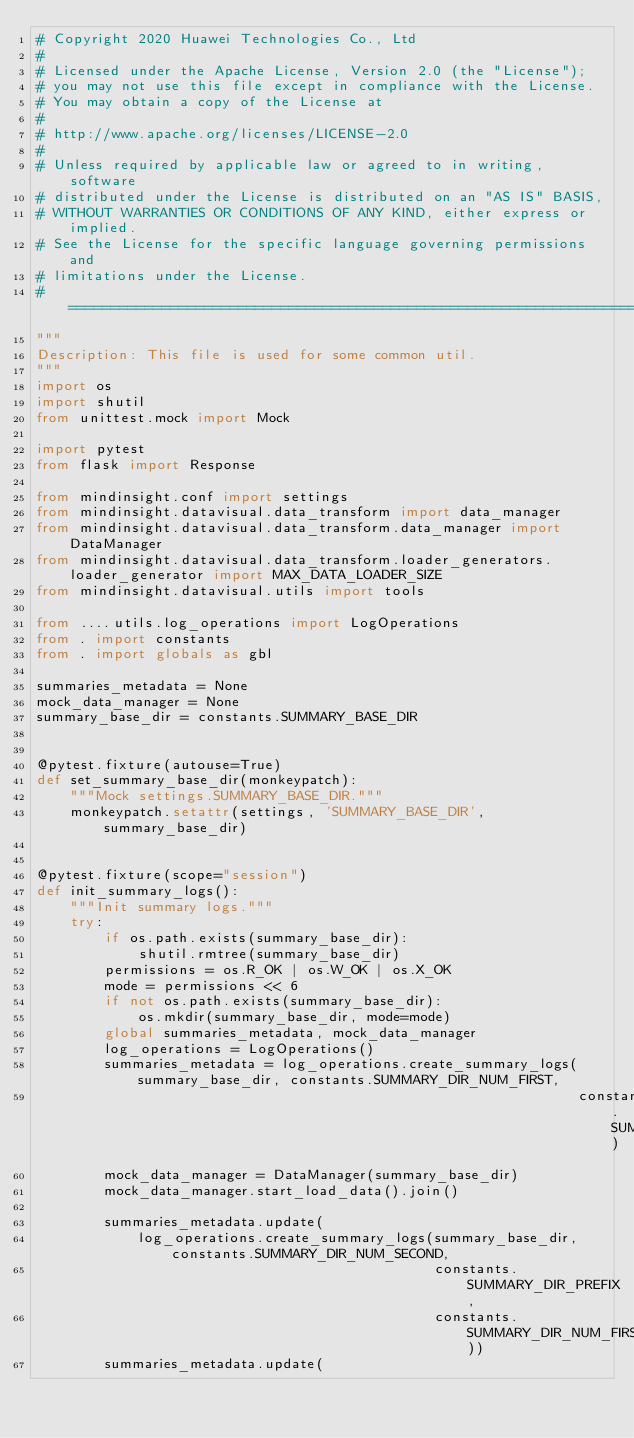Convert code to text. <code><loc_0><loc_0><loc_500><loc_500><_Python_># Copyright 2020 Huawei Technologies Co., Ltd
#
# Licensed under the Apache License, Version 2.0 (the "License");
# you may not use this file except in compliance with the License.
# You may obtain a copy of the License at
#
# http://www.apache.org/licenses/LICENSE-2.0
#
# Unless required by applicable law or agreed to in writing, software
# distributed under the License is distributed on an "AS IS" BASIS,
# WITHOUT WARRANTIES OR CONDITIONS OF ANY KIND, either express or implied.
# See the License for the specific language governing permissions and
# limitations under the License.
# ============================================================================
"""
Description: This file is used for some common util.
"""
import os
import shutil
from unittest.mock import Mock

import pytest
from flask import Response

from mindinsight.conf import settings
from mindinsight.datavisual.data_transform import data_manager
from mindinsight.datavisual.data_transform.data_manager import DataManager
from mindinsight.datavisual.data_transform.loader_generators.loader_generator import MAX_DATA_LOADER_SIZE
from mindinsight.datavisual.utils import tools

from ....utils.log_operations import LogOperations
from . import constants
from . import globals as gbl

summaries_metadata = None
mock_data_manager = None
summary_base_dir = constants.SUMMARY_BASE_DIR


@pytest.fixture(autouse=True)
def set_summary_base_dir(monkeypatch):
    """Mock settings.SUMMARY_BASE_DIR."""
    monkeypatch.setattr(settings, 'SUMMARY_BASE_DIR', summary_base_dir)


@pytest.fixture(scope="session")
def init_summary_logs():
    """Init summary logs."""
    try:
        if os.path.exists(summary_base_dir):
            shutil.rmtree(summary_base_dir)
        permissions = os.R_OK | os.W_OK | os.X_OK
        mode = permissions << 6
        if not os.path.exists(summary_base_dir):
            os.mkdir(summary_base_dir, mode=mode)
        global summaries_metadata, mock_data_manager
        log_operations = LogOperations()
        summaries_metadata = log_operations.create_summary_logs(summary_base_dir, constants.SUMMARY_DIR_NUM_FIRST,
                                                                constants.SUMMARY_DIR_PREFIX)
        mock_data_manager = DataManager(summary_base_dir)
        mock_data_manager.start_load_data().join()

        summaries_metadata.update(
            log_operations.create_summary_logs(summary_base_dir, constants.SUMMARY_DIR_NUM_SECOND,
                                               constants.SUMMARY_DIR_PREFIX,
                                               constants.SUMMARY_DIR_NUM_FIRST))
        summaries_metadata.update(</code> 